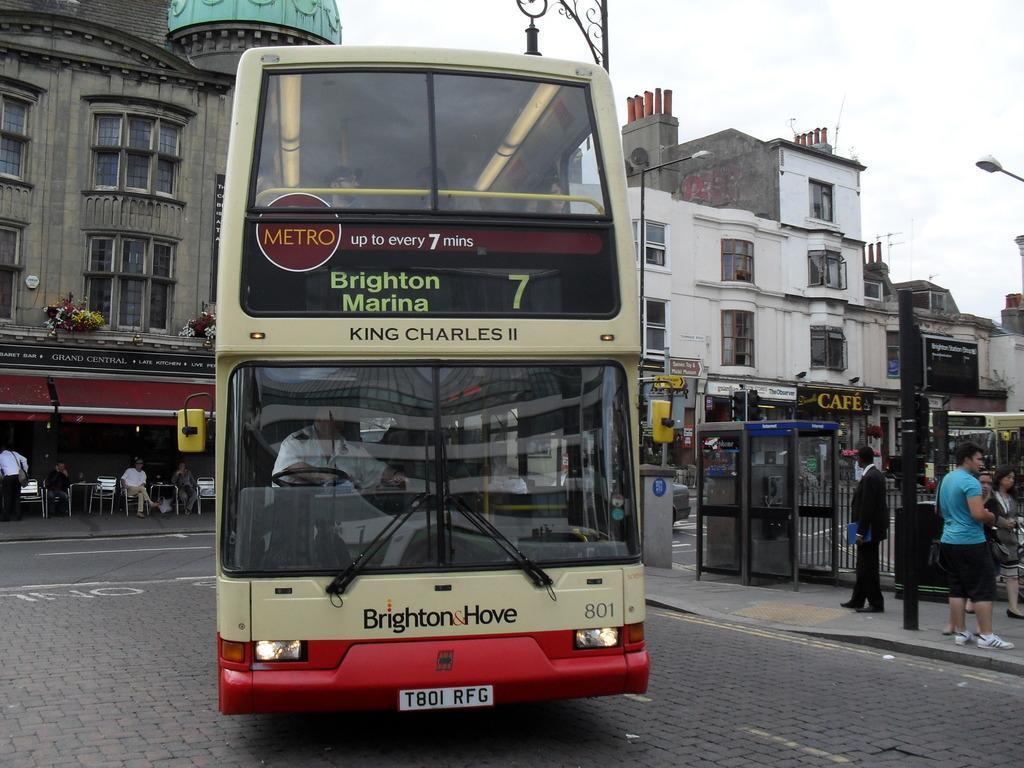Could you give a brief overview of what you see in this image? In this image there is a double decker bus on the road. Left side there are few chairs. Few persons are sitting on it which are under the roof of the building. Right side there are few persons standing on the pavement having a pole and a cabin are on it. Few vehicles are on the road. Background there are few buildings. Top of image there is sky. 